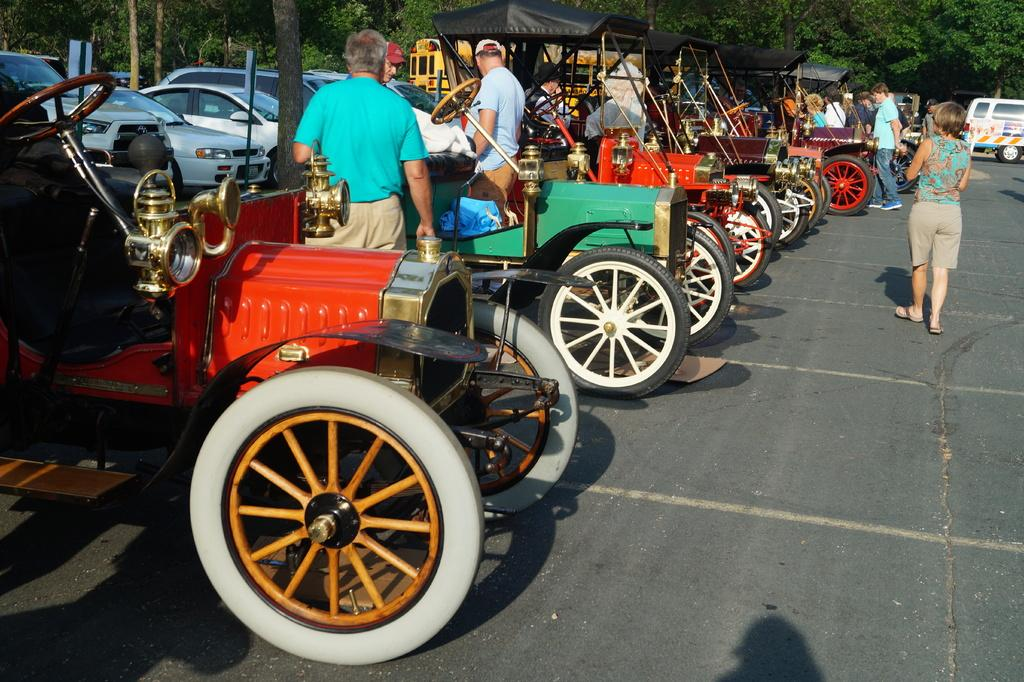What can be seen on the road in the image? There are vehicles on the road in the image. What else is present in the image besides the vehicles? There is a group of people standing in the image. What objects are present with poles in the image? There are boards with poles in the image. What can be seen in the distance in the image? There are trees visible in the background of the image. Where is the nut being used in the image? There is no nut present in the image. What type of cable can be seen connecting the vehicles in the image? There is no cable connecting the vehicles in the image; they are separate entities. 